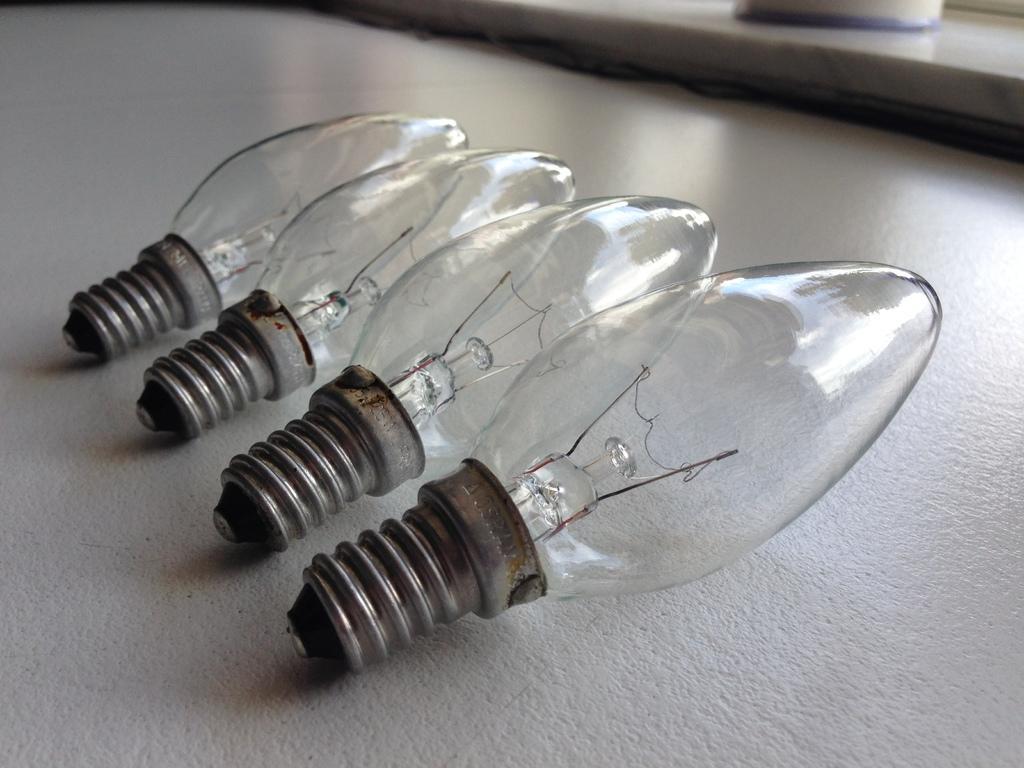In one or two sentences, can you explain what this image depicts? This picture might be taken inside the room. In this image, there is a table. On that table, we can see four bulbs and the table is in white color. 